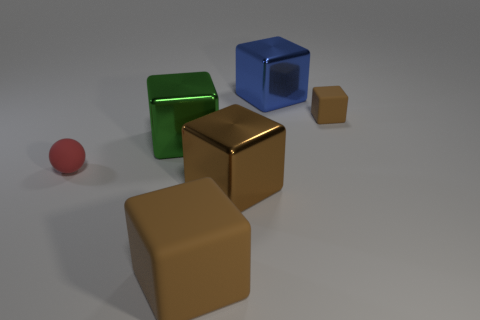Do the matte block that is behind the small red matte thing and the shiny thing in front of the red object have the same color?
Offer a very short reply. Yes. Is the shape of the blue metal object the same as the red object?
Ensure brevity in your answer.  No. There is a small block that is the same color as the large rubber object; what material is it?
Offer a very short reply. Rubber. Does the red thing have the same size as the blue thing?
Give a very brief answer. No. There is another metallic cube that is the same color as the small block; what size is it?
Ensure brevity in your answer.  Large. The small thing that is to the left of the brown metal block has what shape?
Your answer should be compact. Sphere. There is a green metal object; is it the same size as the red object in front of the small brown matte block?
Keep it short and to the point. No. How many rubber objects have the same color as the tiny rubber cube?
Provide a short and direct response. 1. There is a matte thing that is both behind the large rubber cube and in front of the green metallic object; what is its shape?
Your answer should be very brief. Sphere. What number of things are either large metallic things behind the small brown cube or small rubber spheres?
Make the answer very short. 2. 